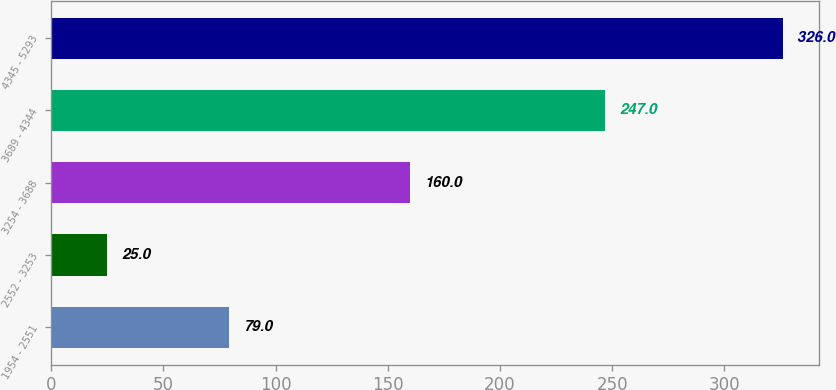<chart> <loc_0><loc_0><loc_500><loc_500><bar_chart><fcel>1954 - 2551<fcel>2552 - 3253<fcel>3254 - 3688<fcel>3689 - 4344<fcel>4345 - 5293<nl><fcel>79<fcel>25<fcel>160<fcel>247<fcel>326<nl></chart> 